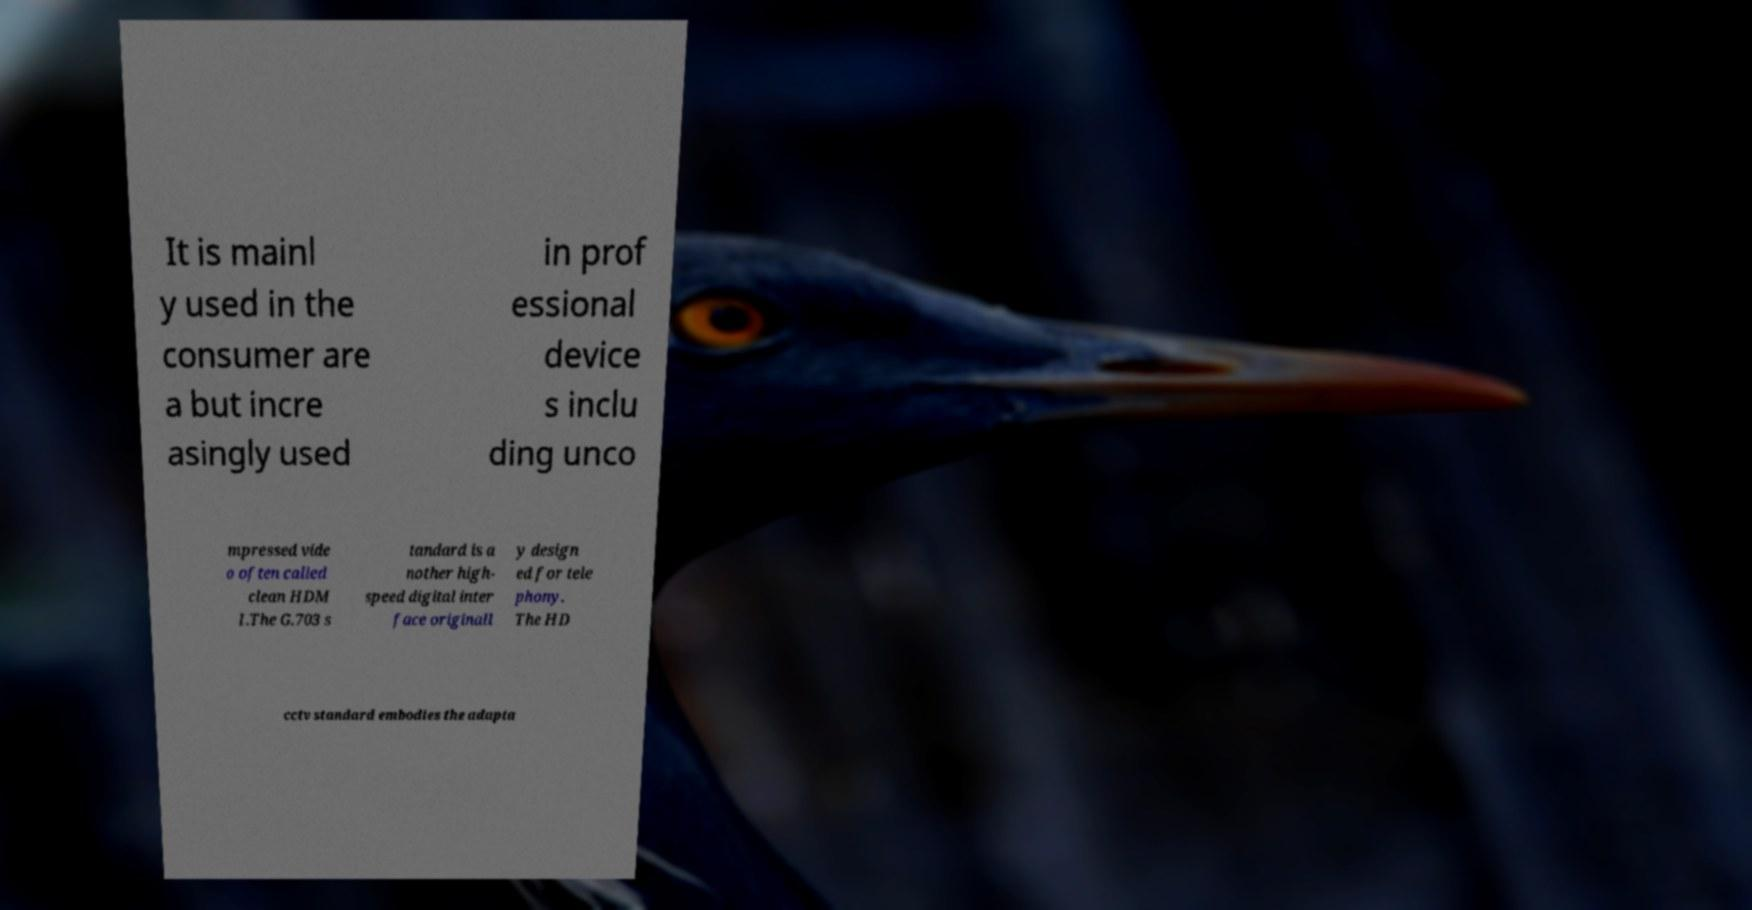There's text embedded in this image that I need extracted. Can you transcribe it verbatim? It is mainl y used in the consumer are a but incre asingly used in prof essional device s inclu ding unco mpressed vide o often called clean HDM I.The G.703 s tandard is a nother high- speed digital inter face originall y design ed for tele phony. The HD cctv standard embodies the adapta 